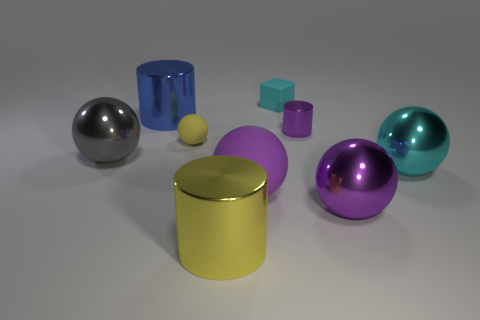Subtract all gray spheres. How many spheres are left? 4 Subtract all yellow rubber balls. How many balls are left? 4 Subtract all brown spheres. Subtract all green blocks. How many spheres are left? 5 Add 1 blue shiny cylinders. How many objects exist? 10 Subtract all cylinders. How many objects are left? 6 Add 7 purple metallic spheres. How many purple metallic spheres are left? 8 Add 6 cylinders. How many cylinders exist? 9 Subtract 0 yellow blocks. How many objects are left? 9 Subtract all small purple metallic spheres. Subtract all tiny purple things. How many objects are left? 8 